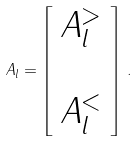Convert formula to latex. <formula><loc_0><loc_0><loc_500><loc_500>A _ { l } = \left [ \begin{array} { c } A ^ { > } _ { l } \\ \\ A ^ { < } _ { l } \end{array} \right ] \, .</formula> 